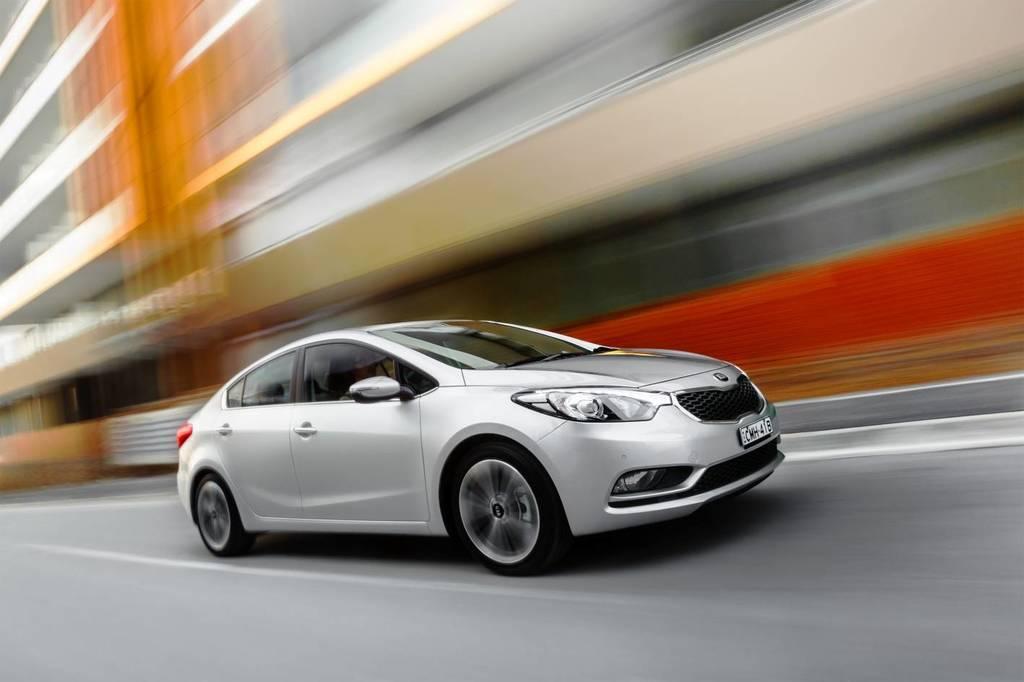Describe this image in one or two sentences. In this image we can see a car on the road. On the backside we can see a building. 